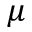Convert formula to latex. <formula><loc_0><loc_0><loc_500><loc_500>\mu</formula> 